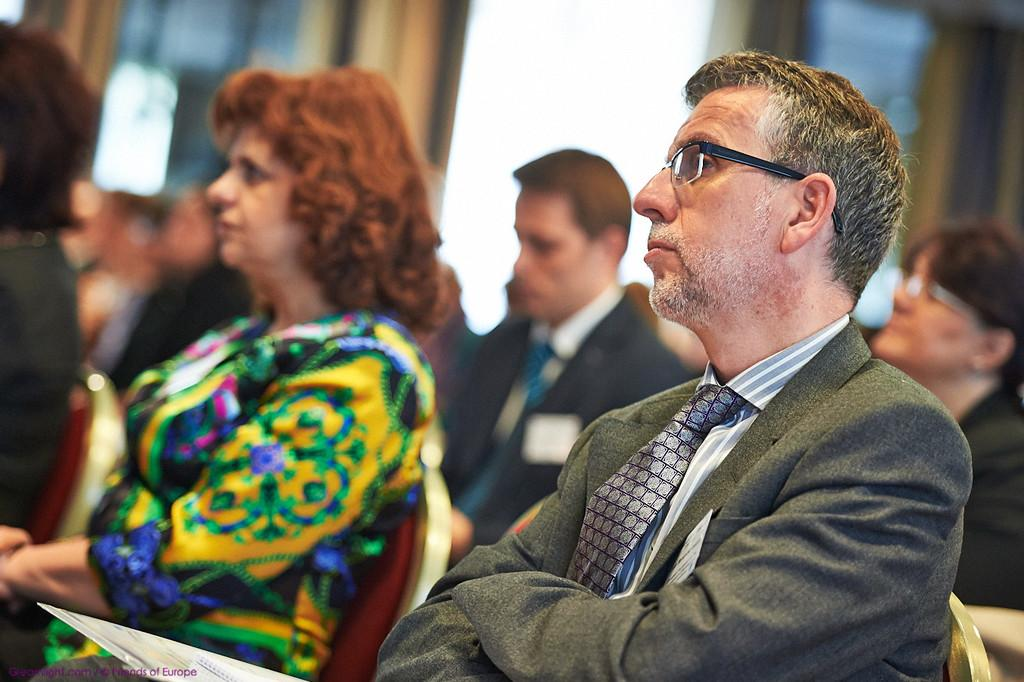What is the main subject of the image? The main subject of the image is a group of people. What are the people in the image doing? The people are sitting on chairs in the image. Can you describe the background of the image? The background of the image is blurred. Is there any additional information or markings on the image? Yes, the image has a watermark. What type of flower is growing on the sidewalk in the image? There is no sidewalk or flower present in the image. How many times do the people in the image fold their chairs? The people in the image are sitting on chairs, not folding them, so this action cannot be observed. 